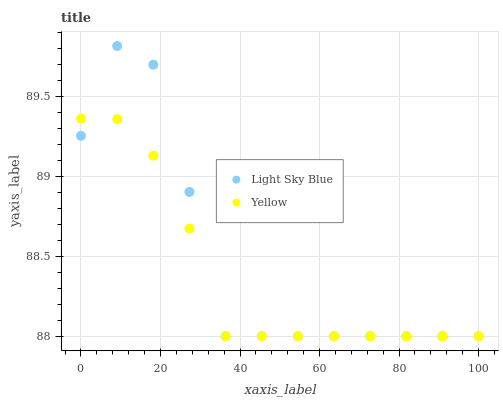Does Yellow have the minimum area under the curve?
Answer yes or no. Yes. Does Light Sky Blue have the maximum area under the curve?
Answer yes or no. Yes. Does Yellow have the maximum area under the curve?
Answer yes or no. No. Is Yellow the smoothest?
Answer yes or no. Yes. Is Light Sky Blue the roughest?
Answer yes or no. Yes. Is Yellow the roughest?
Answer yes or no. No. Does Light Sky Blue have the lowest value?
Answer yes or no. Yes. Does Light Sky Blue have the highest value?
Answer yes or no. Yes. Does Yellow have the highest value?
Answer yes or no. No. Does Light Sky Blue intersect Yellow?
Answer yes or no. Yes. Is Light Sky Blue less than Yellow?
Answer yes or no. No. Is Light Sky Blue greater than Yellow?
Answer yes or no. No. 